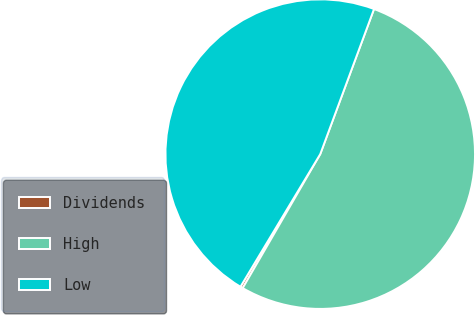Convert chart. <chart><loc_0><loc_0><loc_500><loc_500><pie_chart><fcel>Dividends<fcel>High<fcel>Low<nl><fcel>0.27%<fcel>52.7%<fcel>47.03%<nl></chart> 